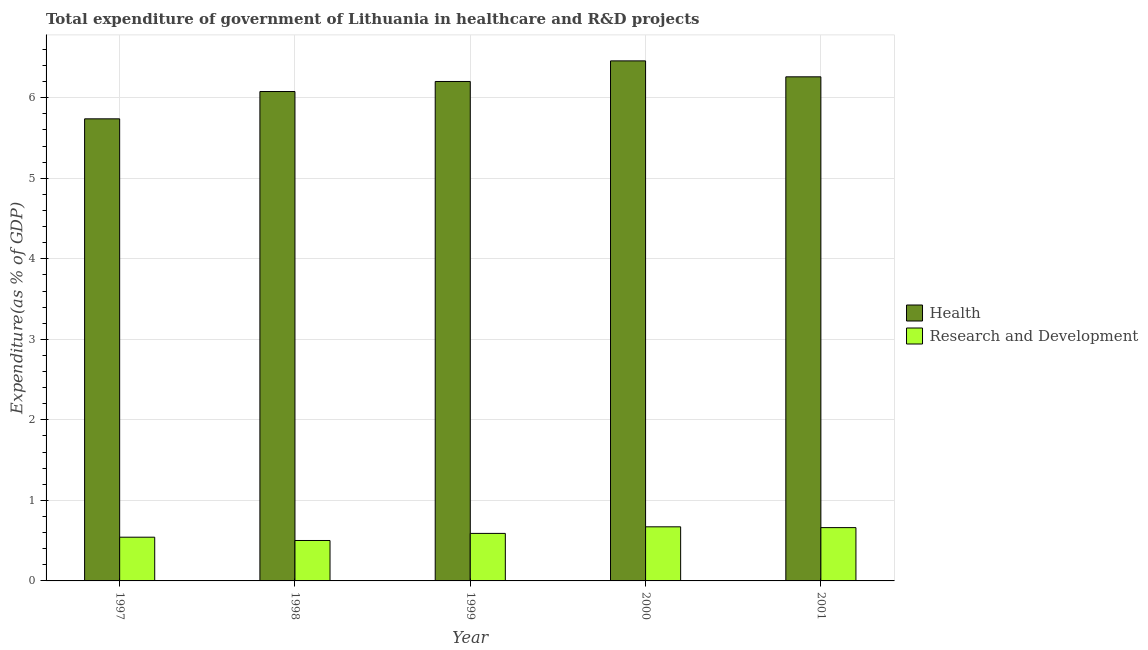How many different coloured bars are there?
Offer a very short reply. 2. How many groups of bars are there?
Your answer should be compact. 5. How many bars are there on the 3rd tick from the left?
Make the answer very short. 2. How many bars are there on the 1st tick from the right?
Make the answer very short. 2. What is the expenditure in healthcare in 1999?
Ensure brevity in your answer.  6.2. Across all years, what is the maximum expenditure in healthcare?
Offer a terse response. 6.46. Across all years, what is the minimum expenditure in r&d?
Offer a very short reply. 0.5. What is the total expenditure in r&d in the graph?
Offer a very short reply. 2.97. What is the difference between the expenditure in r&d in 1997 and that in 1998?
Your response must be concise. 0.04. What is the difference between the expenditure in r&d in 1998 and the expenditure in healthcare in 2000?
Provide a short and direct response. -0.17. What is the average expenditure in r&d per year?
Your response must be concise. 0.59. In how many years, is the expenditure in healthcare greater than 1.4 %?
Offer a very short reply. 5. What is the ratio of the expenditure in r&d in 1999 to that in 2000?
Your response must be concise. 0.88. Is the expenditure in healthcare in 1998 less than that in 2000?
Provide a short and direct response. Yes. Is the difference between the expenditure in healthcare in 1999 and 2000 greater than the difference between the expenditure in r&d in 1999 and 2000?
Give a very brief answer. No. What is the difference between the highest and the second highest expenditure in healthcare?
Your answer should be compact. 0.2. What is the difference between the highest and the lowest expenditure in healthcare?
Ensure brevity in your answer.  0.72. Is the sum of the expenditure in healthcare in 2000 and 2001 greater than the maximum expenditure in r&d across all years?
Give a very brief answer. Yes. What does the 2nd bar from the left in 1997 represents?
Make the answer very short. Research and Development. What does the 2nd bar from the right in 1997 represents?
Offer a terse response. Health. How many bars are there?
Give a very brief answer. 10. How many years are there in the graph?
Provide a short and direct response. 5. Are the values on the major ticks of Y-axis written in scientific E-notation?
Ensure brevity in your answer.  No. Does the graph contain any zero values?
Offer a very short reply. No. Does the graph contain grids?
Your answer should be very brief. Yes. Where does the legend appear in the graph?
Make the answer very short. Center right. How many legend labels are there?
Keep it short and to the point. 2. What is the title of the graph?
Keep it short and to the point. Total expenditure of government of Lithuania in healthcare and R&D projects. Does "Underweight" appear as one of the legend labels in the graph?
Your response must be concise. No. What is the label or title of the Y-axis?
Your answer should be very brief. Expenditure(as % of GDP). What is the Expenditure(as % of GDP) of Health in 1997?
Ensure brevity in your answer.  5.74. What is the Expenditure(as % of GDP) of Research and Development in 1997?
Your answer should be compact. 0.54. What is the Expenditure(as % of GDP) in Health in 1998?
Offer a very short reply. 6.08. What is the Expenditure(as % of GDP) in Research and Development in 1998?
Provide a succinct answer. 0.5. What is the Expenditure(as % of GDP) in Health in 1999?
Keep it short and to the point. 6.2. What is the Expenditure(as % of GDP) of Research and Development in 1999?
Your answer should be compact. 0.59. What is the Expenditure(as % of GDP) in Health in 2000?
Make the answer very short. 6.46. What is the Expenditure(as % of GDP) in Research and Development in 2000?
Your answer should be compact. 0.67. What is the Expenditure(as % of GDP) in Health in 2001?
Offer a terse response. 6.26. What is the Expenditure(as % of GDP) in Research and Development in 2001?
Make the answer very short. 0.66. Across all years, what is the maximum Expenditure(as % of GDP) of Health?
Provide a short and direct response. 6.46. Across all years, what is the maximum Expenditure(as % of GDP) of Research and Development?
Provide a succinct answer. 0.67. Across all years, what is the minimum Expenditure(as % of GDP) in Health?
Keep it short and to the point. 5.74. Across all years, what is the minimum Expenditure(as % of GDP) of Research and Development?
Provide a short and direct response. 0.5. What is the total Expenditure(as % of GDP) in Health in the graph?
Provide a short and direct response. 30.74. What is the total Expenditure(as % of GDP) of Research and Development in the graph?
Provide a succinct answer. 2.97. What is the difference between the Expenditure(as % of GDP) in Health in 1997 and that in 1998?
Your answer should be very brief. -0.34. What is the difference between the Expenditure(as % of GDP) of Research and Development in 1997 and that in 1998?
Your response must be concise. 0.04. What is the difference between the Expenditure(as % of GDP) in Health in 1997 and that in 1999?
Ensure brevity in your answer.  -0.46. What is the difference between the Expenditure(as % of GDP) of Research and Development in 1997 and that in 1999?
Provide a succinct answer. -0.05. What is the difference between the Expenditure(as % of GDP) of Health in 1997 and that in 2000?
Your answer should be very brief. -0.72. What is the difference between the Expenditure(as % of GDP) in Research and Development in 1997 and that in 2000?
Offer a very short reply. -0.13. What is the difference between the Expenditure(as % of GDP) of Health in 1997 and that in 2001?
Provide a short and direct response. -0.52. What is the difference between the Expenditure(as % of GDP) in Research and Development in 1997 and that in 2001?
Your answer should be very brief. -0.12. What is the difference between the Expenditure(as % of GDP) of Health in 1998 and that in 1999?
Your answer should be very brief. -0.12. What is the difference between the Expenditure(as % of GDP) of Research and Development in 1998 and that in 1999?
Provide a succinct answer. -0.09. What is the difference between the Expenditure(as % of GDP) of Health in 1998 and that in 2000?
Make the answer very short. -0.38. What is the difference between the Expenditure(as % of GDP) in Research and Development in 1998 and that in 2000?
Offer a terse response. -0.17. What is the difference between the Expenditure(as % of GDP) in Health in 1998 and that in 2001?
Offer a terse response. -0.18. What is the difference between the Expenditure(as % of GDP) of Research and Development in 1998 and that in 2001?
Offer a very short reply. -0.16. What is the difference between the Expenditure(as % of GDP) in Health in 1999 and that in 2000?
Your answer should be very brief. -0.26. What is the difference between the Expenditure(as % of GDP) in Research and Development in 1999 and that in 2000?
Offer a very short reply. -0.08. What is the difference between the Expenditure(as % of GDP) of Health in 1999 and that in 2001?
Keep it short and to the point. -0.06. What is the difference between the Expenditure(as % of GDP) in Research and Development in 1999 and that in 2001?
Offer a terse response. -0.07. What is the difference between the Expenditure(as % of GDP) of Health in 2000 and that in 2001?
Provide a short and direct response. 0.2. What is the difference between the Expenditure(as % of GDP) in Research and Development in 2000 and that in 2001?
Provide a short and direct response. 0.01. What is the difference between the Expenditure(as % of GDP) of Health in 1997 and the Expenditure(as % of GDP) of Research and Development in 1998?
Ensure brevity in your answer.  5.24. What is the difference between the Expenditure(as % of GDP) of Health in 1997 and the Expenditure(as % of GDP) of Research and Development in 1999?
Provide a short and direct response. 5.15. What is the difference between the Expenditure(as % of GDP) in Health in 1997 and the Expenditure(as % of GDP) in Research and Development in 2000?
Your answer should be compact. 5.07. What is the difference between the Expenditure(as % of GDP) of Health in 1997 and the Expenditure(as % of GDP) of Research and Development in 2001?
Provide a short and direct response. 5.08. What is the difference between the Expenditure(as % of GDP) in Health in 1998 and the Expenditure(as % of GDP) in Research and Development in 1999?
Keep it short and to the point. 5.49. What is the difference between the Expenditure(as % of GDP) in Health in 1998 and the Expenditure(as % of GDP) in Research and Development in 2000?
Provide a succinct answer. 5.41. What is the difference between the Expenditure(as % of GDP) in Health in 1998 and the Expenditure(as % of GDP) in Research and Development in 2001?
Provide a short and direct response. 5.42. What is the difference between the Expenditure(as % of GDP) in Health in 1999 and the Expenditure(as % of GDP) in Research and Development in 2000?
Make the answer very short. 5.53. What is the difference between the Expenditure(as % of GDP) in Health in 1999 and the Expenditure(as % of GDP) in Research and Development in 2001?
Keep it short and to the point. 5.54. What is the difference between the Expenditure(as % of GDP) in Health in 2000 and the Expenditure(as % of GDP) in Research and Development in 2001?
Offer a terse response. 5.8. What is the average Expenditure(as % of GDP) of Health per year?
Give a very brief answer. 6.15. What is the average Expenditure(as % of GDP) of Research and Development per year?
Provide a short and direct response. 0.59. In the year 1997, what is the difference between the Expenditure(as % of GDP) in Health and Expenditure(as % of GDP) in Research and Development?
Provide a succinct answer. 5.2. In the year 1998, what is the difference between the Expenditure(as % of GDP) of Health and Expenditure(as % of GDP) of Research and Development?
Keep it short and to the point. 5.58. In the year 1999, what is the difference between the Expenditure(as % of GDP) in Health and Expenditure(as % of GDP) in Research and Development?
Give a very brief answer. 5.61. In the year 2000, what is the difference between the Expenditure(as % of GDP) in Health and Expenditure(as % of GDP) in Research and Development?
Offer a very short reply. 5.79. In the year 2001, what is the difference between the Expenditure(as % of GDP) in Health and Expenditure(as % of GDP) in Research and Development?
Make the answer very short. 5.6. What is the ratio of the Expenditure(as % of GDP) of Health in 1997 to that in 1998?
Make the answer very short. 0.94. What is the ratio of the Expenditure(as % of GDP) in Research and Development in 1997 to that in 1998?
Your answer should be very brief. 1.08. What is the ratio of the Expenditure(as % of GDP) of Health in 1997 to that in 1999?
Keep it short and to the point. 0.93. What is the ratio of the Expenditure(as % of GDP) of Research and Development in 1997 to that in 1999?
Provide a short and direct response. 0.92. What is the ratio of the Expenditure(as % of GDP) of Health in 1997 to that in 2000?
Keep it short and to the point. 0.89. What is the ratio of the Expenditure(as % of GDP) in Research and Development in 1997 to that in 2000?
Your answer should be very brief. 0.81. What is the ratio of the Expenditure(as % of GDP) of Health in 1997 to that in 2001?
Provide a succinct answer. 0.92. What is the ratio of the Expenditure(as % of GDP) in Research and Development in 1997 to that in 2001?
Your answer should be very brief. 0.82. What is the ratio of the Expenditure(as % of GDP) of Health in 1998 to that in 1999?
Make the answer very short. 0.98. What is the ratio of the Expenditure(as % of GDP) of Research and Development in 1998 to that in 1999?
Keep it short and to the point. 0.85. What is the ratio of the Expenditure(as % of GDP) in Health in 1998 to that in 2000?
Provide a short and direct response. 0.94. What is the ratio of the Expenditure(as % of GDP) of Research and Development in 1998 to that in 2000?
Provide a succinct answer. 0.75. What is the ratio of the Expenditure(as % of GDP) of Health in 1998 to that in 2001?
Make the answer very short. 0.97. What is the ratio of the Expenditure(as % of GDP) of Research and Development in 1998 to that in 2001?
Your answer should be very brief. 0.76. What is the ratio of the Expenditure(as % of GDP) in Health in 1999 to that in 2000?
Your response must be concise. 0.96. What is the ratio of the Expenditure(as % of GDP) in Research and Development in 1999 to that in 2000?
Ensure brevity in your answer.  0.88. What is the ratio of the Expenditure(as % of GDP) in Health in 1999 to that in 2001?
Ensure brevity in your answer.  0.99. What is the ratio of the Expenditure(as % of GDP) in Research and Development in 1999 to that in 2001?
Your answer should be compact. 0.89. What is the ratio of the Expenditure(as % of GDP) of Health in 2000 to that in 2001?
Provide a short and direct response. 1.03. What is the ratio of the Expenditure(as % of GDP) of Research and Development in 2000 to that in 2001?
Keep it short and to the point. 1.01. What is the difference between the highest and the second highest Expenditure(as % of GDP) of Health?
Provide a succinct answer. 0.2. What is the difference between the highest and the second highest Expenditure(as % of GDP) of Research and Development?
Provide a short and direct response. 0.01. What is the difference between the highest and the lowest Expenditure(as % of GDP) of Health?
Provide a short and direct response. 0.72. What is the difference between the highest and the lowest Expenditure(as % of GDP) of Research and Development?
Your answer should be compact. 0.17. 